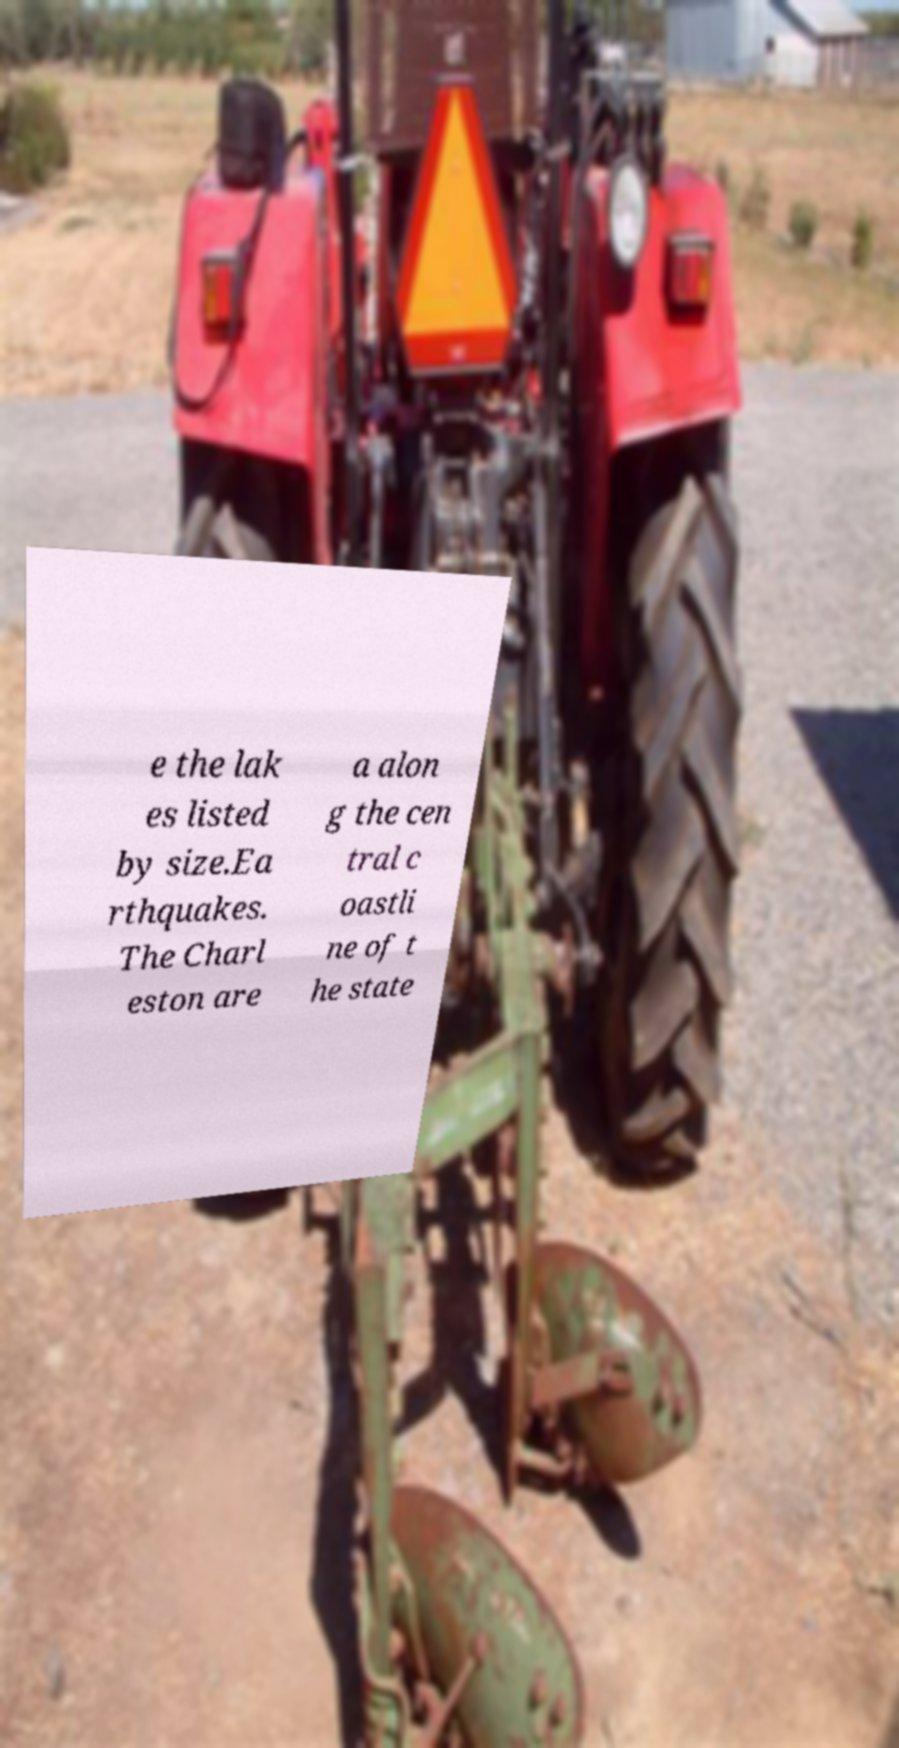Please read and relay the text visible in this image. What does it say? e the lak es listed by size.Ea rthquakes. The Charl eston are a alon g the cen tral c oastli ne of t he state 